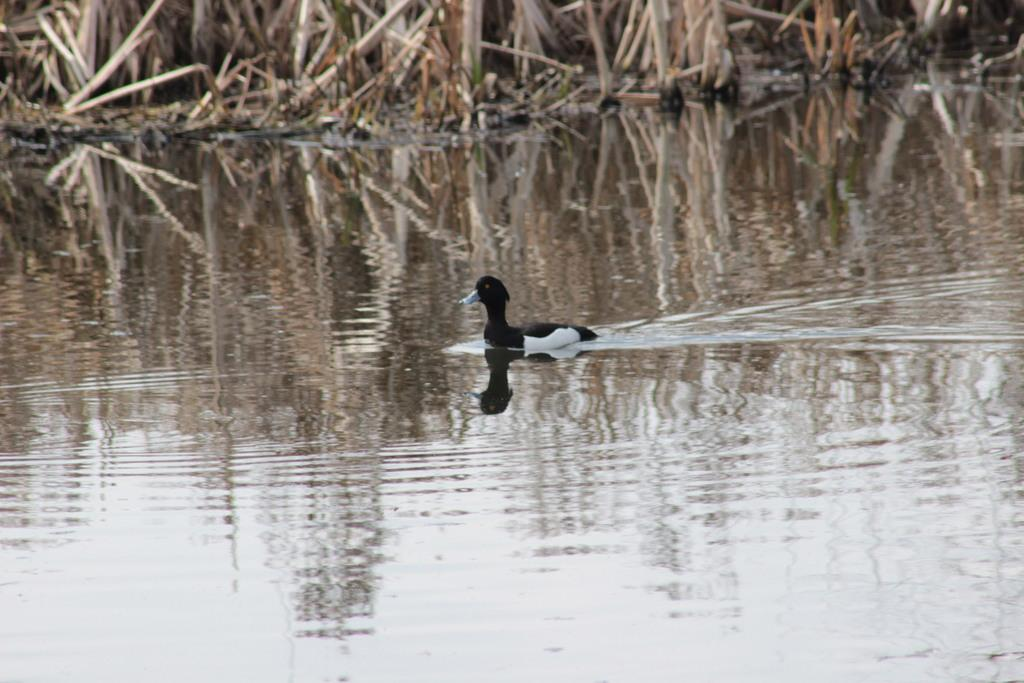What is the color of the object in the image? The object in the image is white and black in color. What can be seen in the image besides the object? There is water visible in the image. What is present in the background of the image? There are plants in the background of the image. Is there a lawyer present in the image? There is no mention of a lawyer or any legal context in the image. 